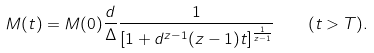Convert formula to latex. <formula><loc_0><loc_0><loc_500><loc_500>M ( t ) = M ( 0 ) \frac { d } { \Delta } \frac { 1 } { [ 1 + d ^ { z - 1 } ( z - 1 ) t ] ^ { \frac { 1 } { z - 1 } } } \quad ( t > T ) .</formula> 